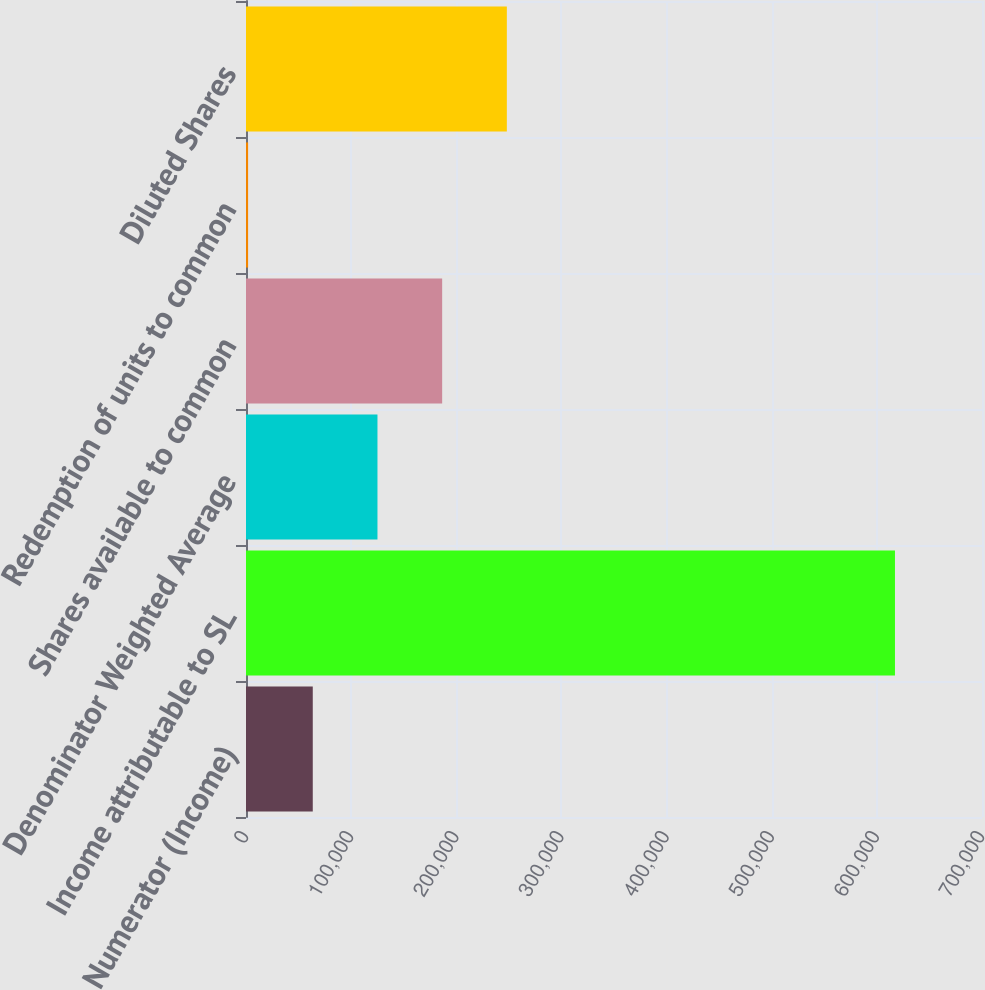Convert chart to OTSL. <chart><loc_0><loc_0><loc_500><loc_500><bar_chart><fcel>Numerator (Income)<fcel>Income attributable to SL<fcel>Denominator Weighted Average<fcel>Shares available to common<fcel>Redemption of units to common<fcel>Diluted Shares<nl><fcel>63509.7<fcel>617232<fcel>125034<fcel>186559<fcel>1985<fcel>248084<nl></chart> 